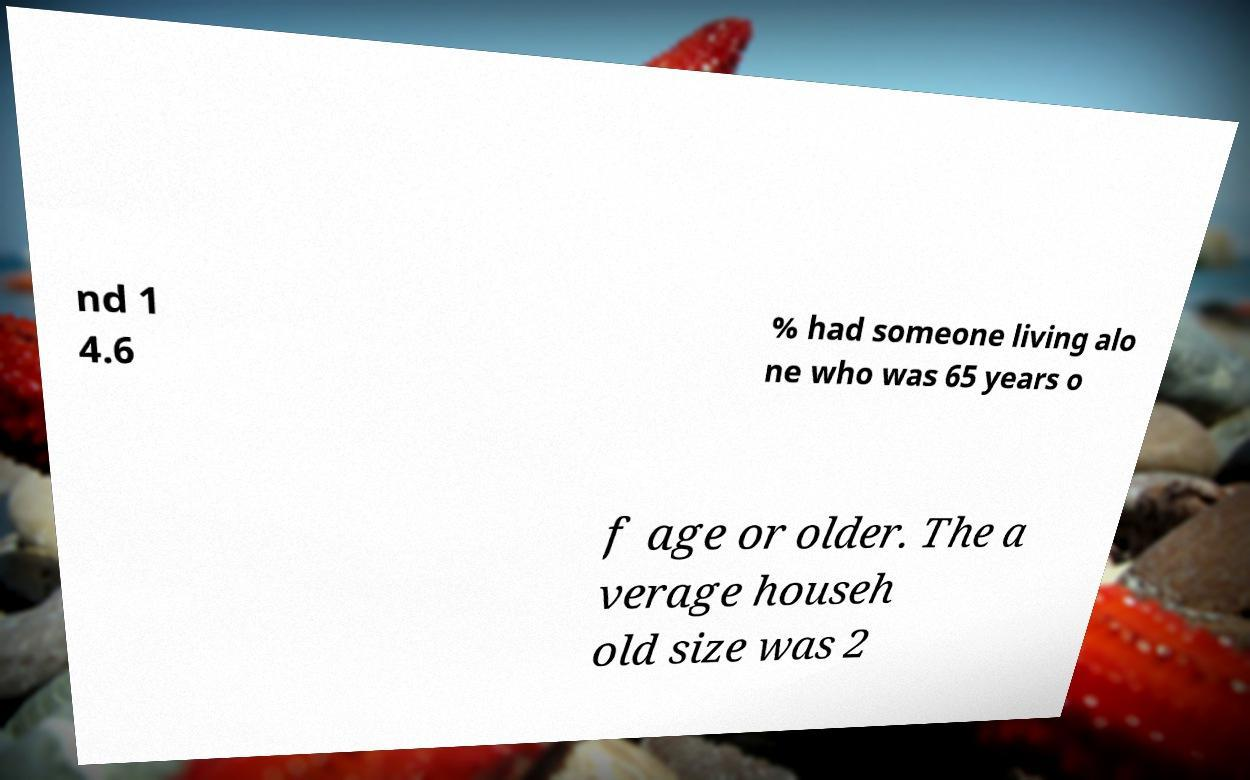Please identify and transcribe the text found in this image. nd 1 4.6 % had someone living alo ne who was 65 years o f age or older. The a verage househ old size was 2 